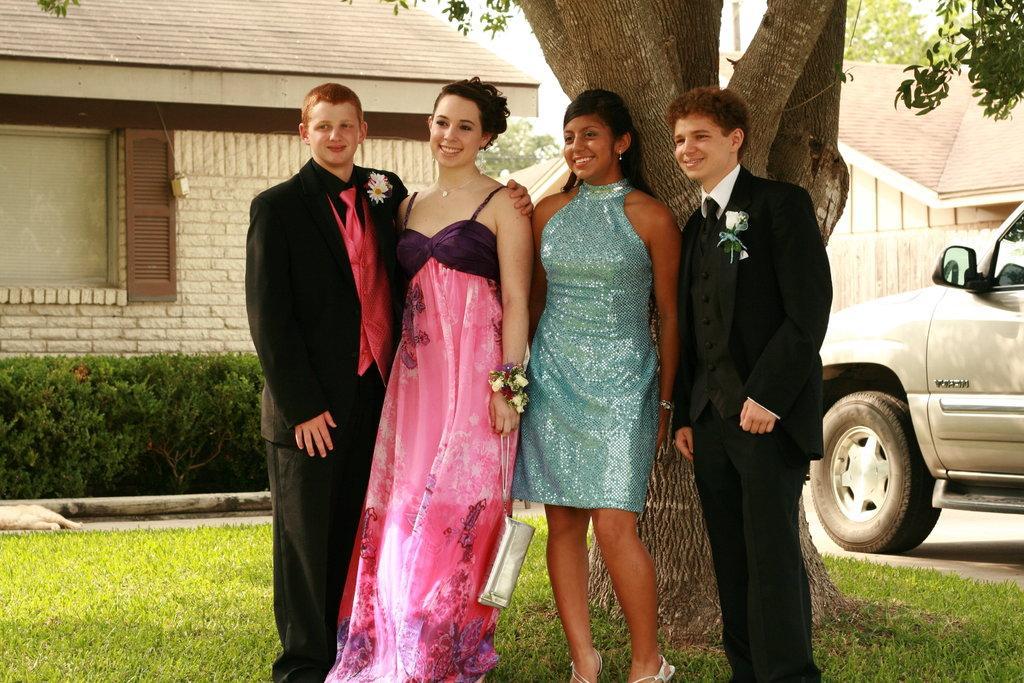Can you describe this image briefly? In this image I can see grass ground and on it I can see four persons are standing, I can see smile on their faces. On the extreme left and on the extreme right side I can see two of them are wearing black colour dress and in the centre I can see one of them is holding a bag. In the background I can see few buildings, few trees, few plants and on the right side of this image I can see a vehicle. 